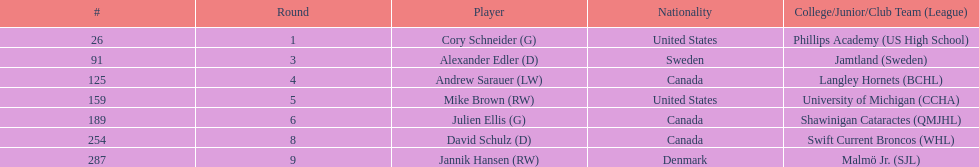How many players are from the united states? 2. 